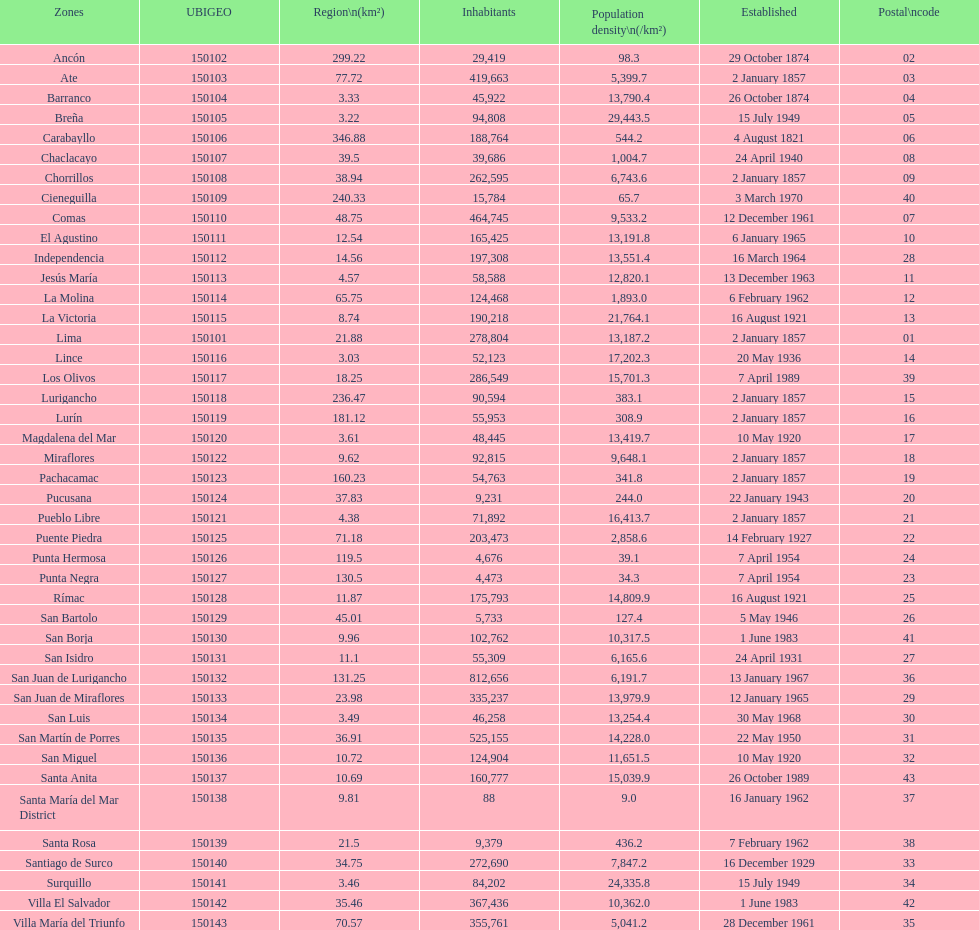How many districts have a population density of at lest 1000.0? 31. 